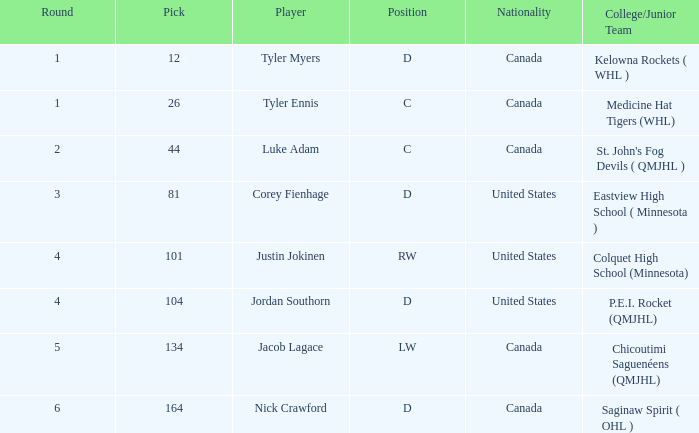What is the college/junior team of player tyler myers, who has a pick less than 44? Kelowna Rockets ( WHL ). I'm looking to parse the entire table for insights. Could you assist me with that? {'header': ['Round', 'Pick', 'Player', 'Position', 'Nationality', 'College/Junior Team'], 'rows': [['1', '12', 'Tyler Myers', 'D', 'Canada', 'Kelowna Rockets ( WHL )'], ['1', '26', 'Tyler Ennis', 'C', 'Canada', 'Medicine Hat Tigers (WHL)'], ['2', '44', 'Luke Adam', 'C', 'Canada', "St. John's Fog Devils ( QMJHL )"], ['3', '81', 'Corey Fienhage', 'D', 'United States', 'Eastview High School ( Minnesota )'], ['4', '101', 'Justin Jokinen', 'RW', 'United States', 'Colquet High School (Minnesota)'], ['4', '104', 'Jordan Southorn', 'D', 'United States', 'P.E.I. Rocket (QMJHL)'], ['5', '134', 'Jacob Lagace', 'LW', 'Canada', 'Chicoutimi Saguenéens (QMJHL)'], ['6', '164', 'Nick Crawford', 'D', 'Canada', 'Saginaw Spirit ( OHL )']]} 